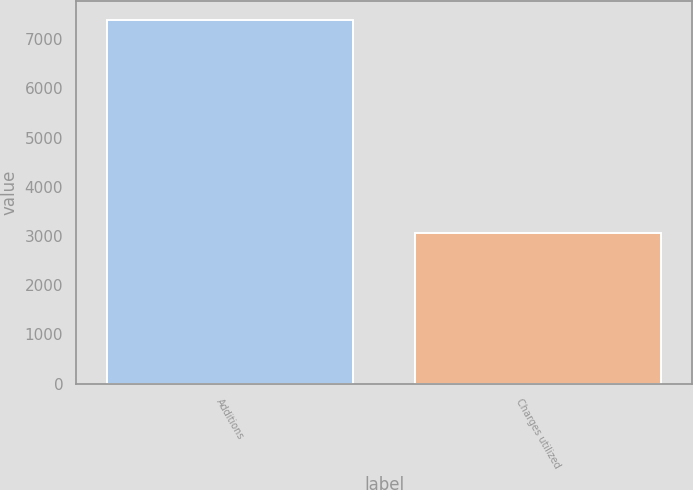Convert chart. <chart><loc_0><loc_0><loc_500><loc_500><bar_chart><fcel>Additions<fcel>Charges utilized<nl><fcel>7397<fcel>3069<nl></chart> 